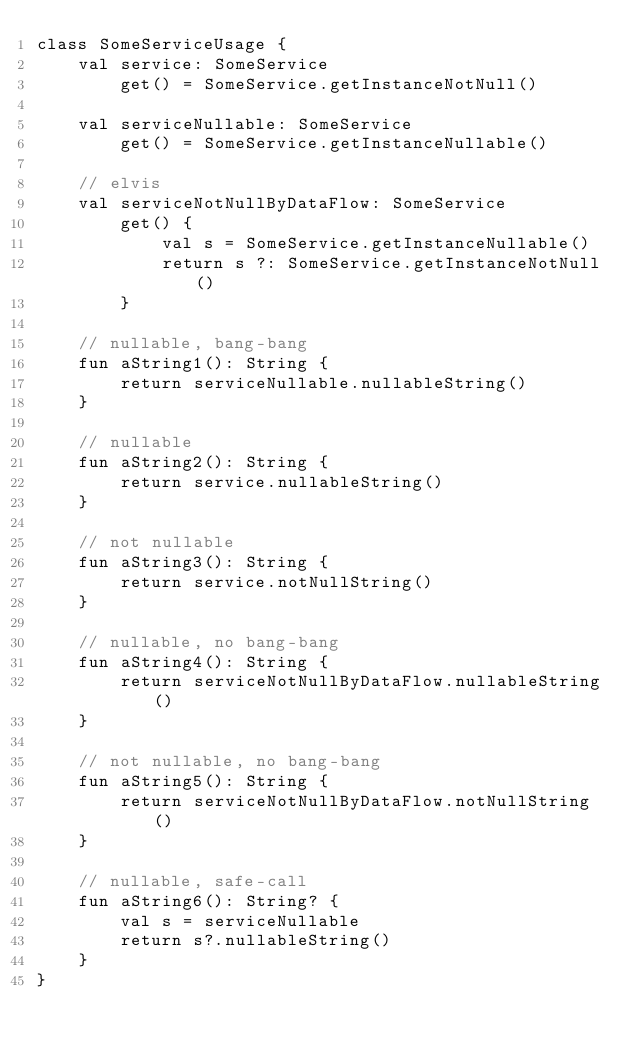<code> <loc_0><loc_0><loc_500><loc_500><_Kotlin_>class SomeServiceUsage {
    val service: SomeService
        get() = SomeService.getInstanceNotNull()

    val serviceNullable: SomeService
        get() = SomeService.getInstanceNullable()

    // elvis
    val serviceNotNullByDataFlow: SomeService
        get() {
            val s = SomeService.getInstanceNullable()
            return s ?: SomeService.getInstanceNotNull()
        }

    // nullable, bang-bang
    fun aString1(): String {
        return serviceNullable.nullableString()
    }

    // nullable
    fun aString2(): String {
        return service.nullableString()
    }

    // not nullable
    fun aString3(): String {
        return service.notNullString()
    }

    // nullable, no bang-bang
    fun aString4(): String {
        return serviceNotNullByDataFlow.nullableString()
    }

    // not nullable, no bang-bang
    fun aString5(): String {
        return serviceNotNullByDataFlow.notNullString()
    }

    // nullable, safe-call
    fun aString6(): String? {
        val s = serviceNullable
        return s?.nullableString()
    }
}</code> 